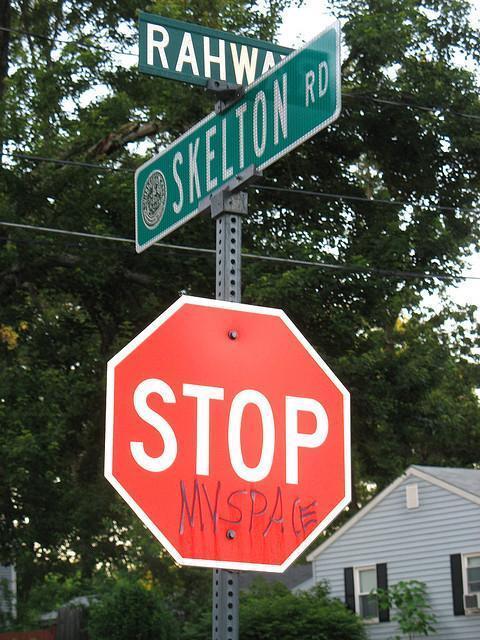How many dogs are on a leash?
Give a very brief answer. 0. 